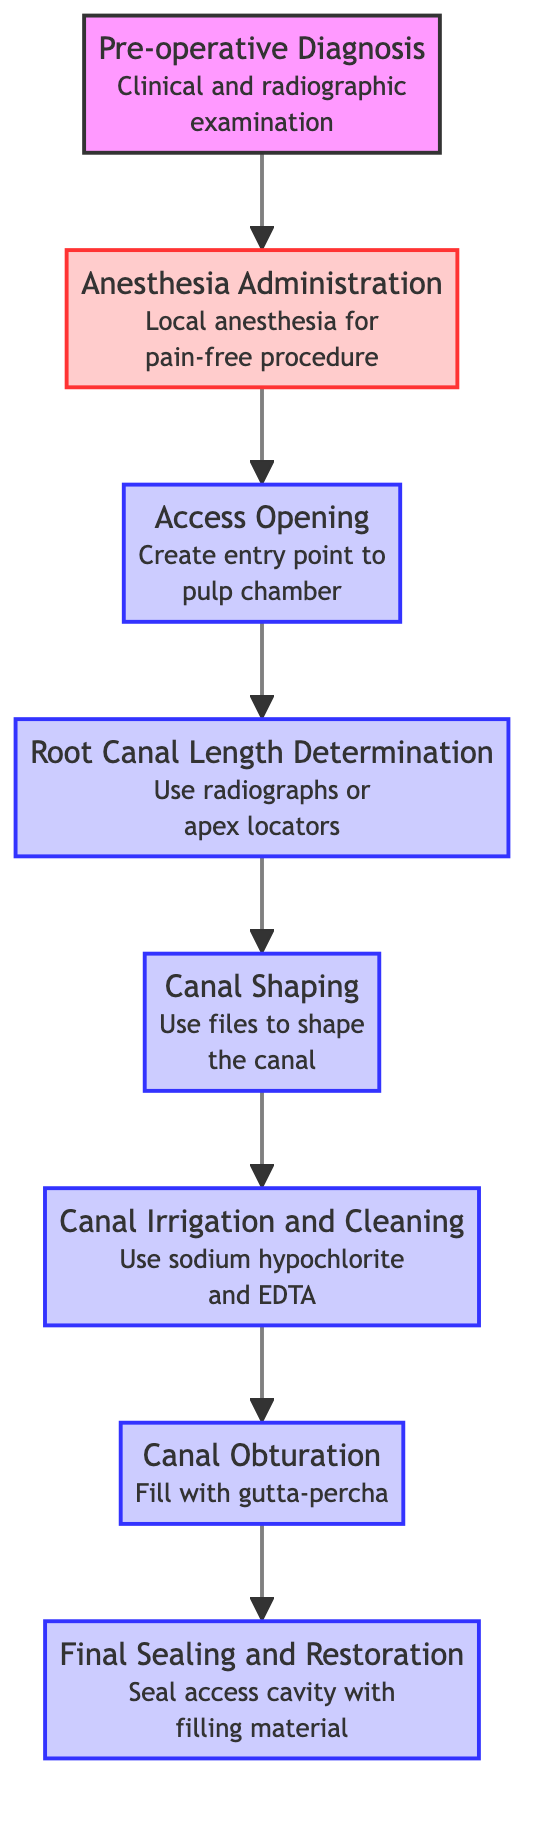What is the first step in the root canal treatment process? The first step in the flowchart is labeled as "Pre-operative Diagnosis." It is indicated at the bottom before any other steps, implying that it is the initiating action.
Answer: Pre-operative Diagnosis How many steps are there in the diagram? The diagram outlines a total of 7 distinct steps from "Pre-operative Diagnosis" to "Final Sealing and Restoration." Each step corresponds to actions in the treatment process.
Answer: 7 What is the next step after "Anesthesia Administration"? Following "Anesthesia Administration," the flowchart points to "Access Opening." This indicates that creating an entry point in the pulp chamber is the next action after anesthesia is given.
Answer: Access Opening What is done during "Canal Irrigation and Cleaning"? "Canal Irrigation and Cleaning" involves irrigating the canal with sodium hypochlorite and EDTA, as stated in the description provided in the diagram.
Answer: Sodium hypochlorite and EDTA Which step comes directly before "Final Sealing and Restoration"? The step immediately preceding "Final Sealing and Restoration" is "Canal Obturation." This means that the canals must be filled before sealing the access cavity.
Answer: Canal Obturation Which step requires the use of radiographs or apex locators? The "Root Canal Length Determination" step requires radiographs or apex locators to establish the correct working length of the canal during the treatment process.
Answer: Root Canal Length Determination Is "Anesthesia Administration" a required action before access opening? Yes, "Anesthesia Administration" is a necessary step before performing the "Access Opening." The flowchart indicates a direct connection indicating its requirement prior to this step.
Answer: Yes What is the importance of "Final Sealing and Restoration"? The "Final Sealing and Restoration" step is crucial as it seals the access cavity with dental filling material, preventing potential re-infection after the root canal treatment.
Answer: Prevent re-infection 